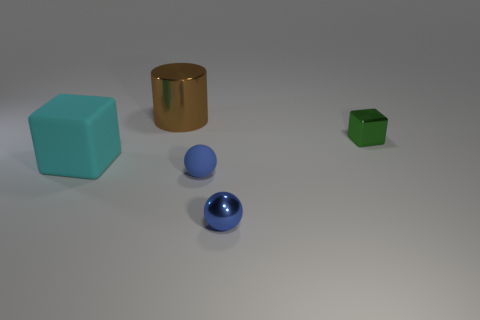Does the big thing that is to the left of the brown metallic thing have the same material as the big cylinder?
Keep it short and to the point. No. Is there a big matte thing that has the same color as the metal ball?
Offer a terse response. No. Are any small blue rubber spheres visible?
Provide a succinct answer. Yes. Is the size of the thing to the left of the shiny cylinder the same as the green object?
Provide a short and direct response. No. Are there fewer green metal objects than tiny yellow rubber objects?
Your response must be concise. No. The metallic object behind the cube right of the block to the left of the metal cylinder is what shape?
Your answer should be very brief. Cylinder. Are there any brown cylinders that have the same material as the large brown object?
Your answer should be compact. No. Is the color of the cube that is on the right side of the brown thing the same as the rubber object that is on the right side of the metal cylinder?
Provide a succinct answer. No. Is the number of green cubes that are on the left side of the tiny green metallic thing less than the number of big cyan rubber balls?
Keep it short and to the point. No. What number of objects are either large rubber things or objects that are on the left side of the brown metallic object?
Your answer should be compact. 1. 